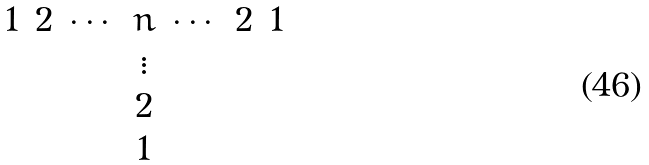<formula> <loc_0><loc_0><loc_500><loc_500>\begin{matrix} 1 & 2 & \cdots & n & \cdots & 2 & 1 \\ & & & \vdots & & & \\ & & & 2 & & & \\ & & & 1 & & & \end{matrix}</formula> 